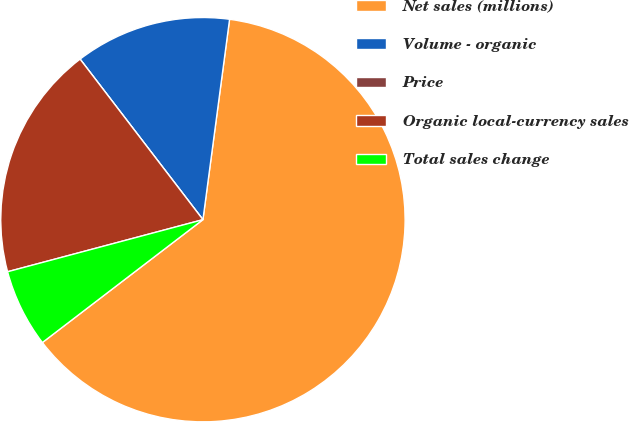Convert chart to OTSL. <chart><loc_0><loc_0><loc_500><loc_500><pie_chart><fcel>Net sales (millions)<fcel>Volume - organic<fcel>Price<fcel>Organic local-currency sales<fcel>Total sales change<nl><fcel>62.5%<fcel>12.5%<fcel>0.0%<fcel>18.75%<fcel>6.25%<nl></chart> 